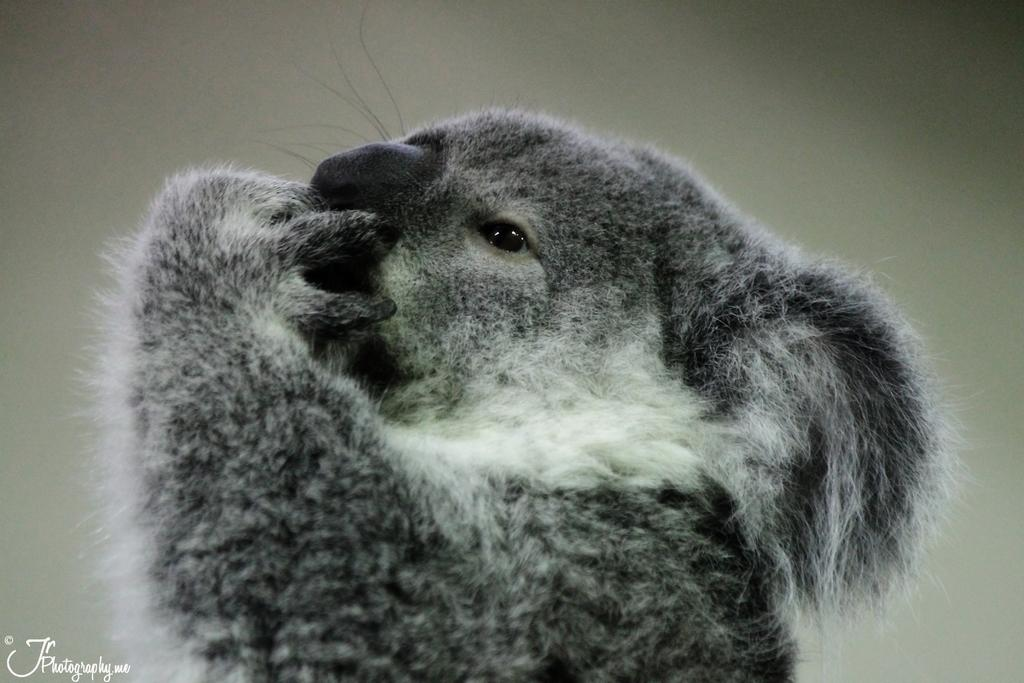What type of animal is in the picture? There is a koala in the picture. Can you describe the color of the koala? The koala is gray in color with some white fur. What part of the koala's body is near its nose? The koala's hand is near its nose. What color is the koala's nose? The koala's nose is black in color. What type of breakfast is the koala eating in the picture? There is no breakfast present in the image; it only features a koala. 